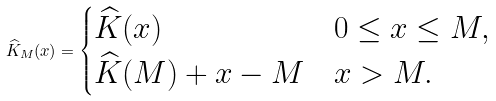Convert formula to latex. <formula><loc_0><loc_0><loc_500><loc_500>\widehat { K } _ { M } ( x ) = \begin{cases} \widehat { K } ( x ) & 0 \leq x \leq M , \\ \widehat { K } ( M ) + x - M & x > M . \end{cases}</formula> 